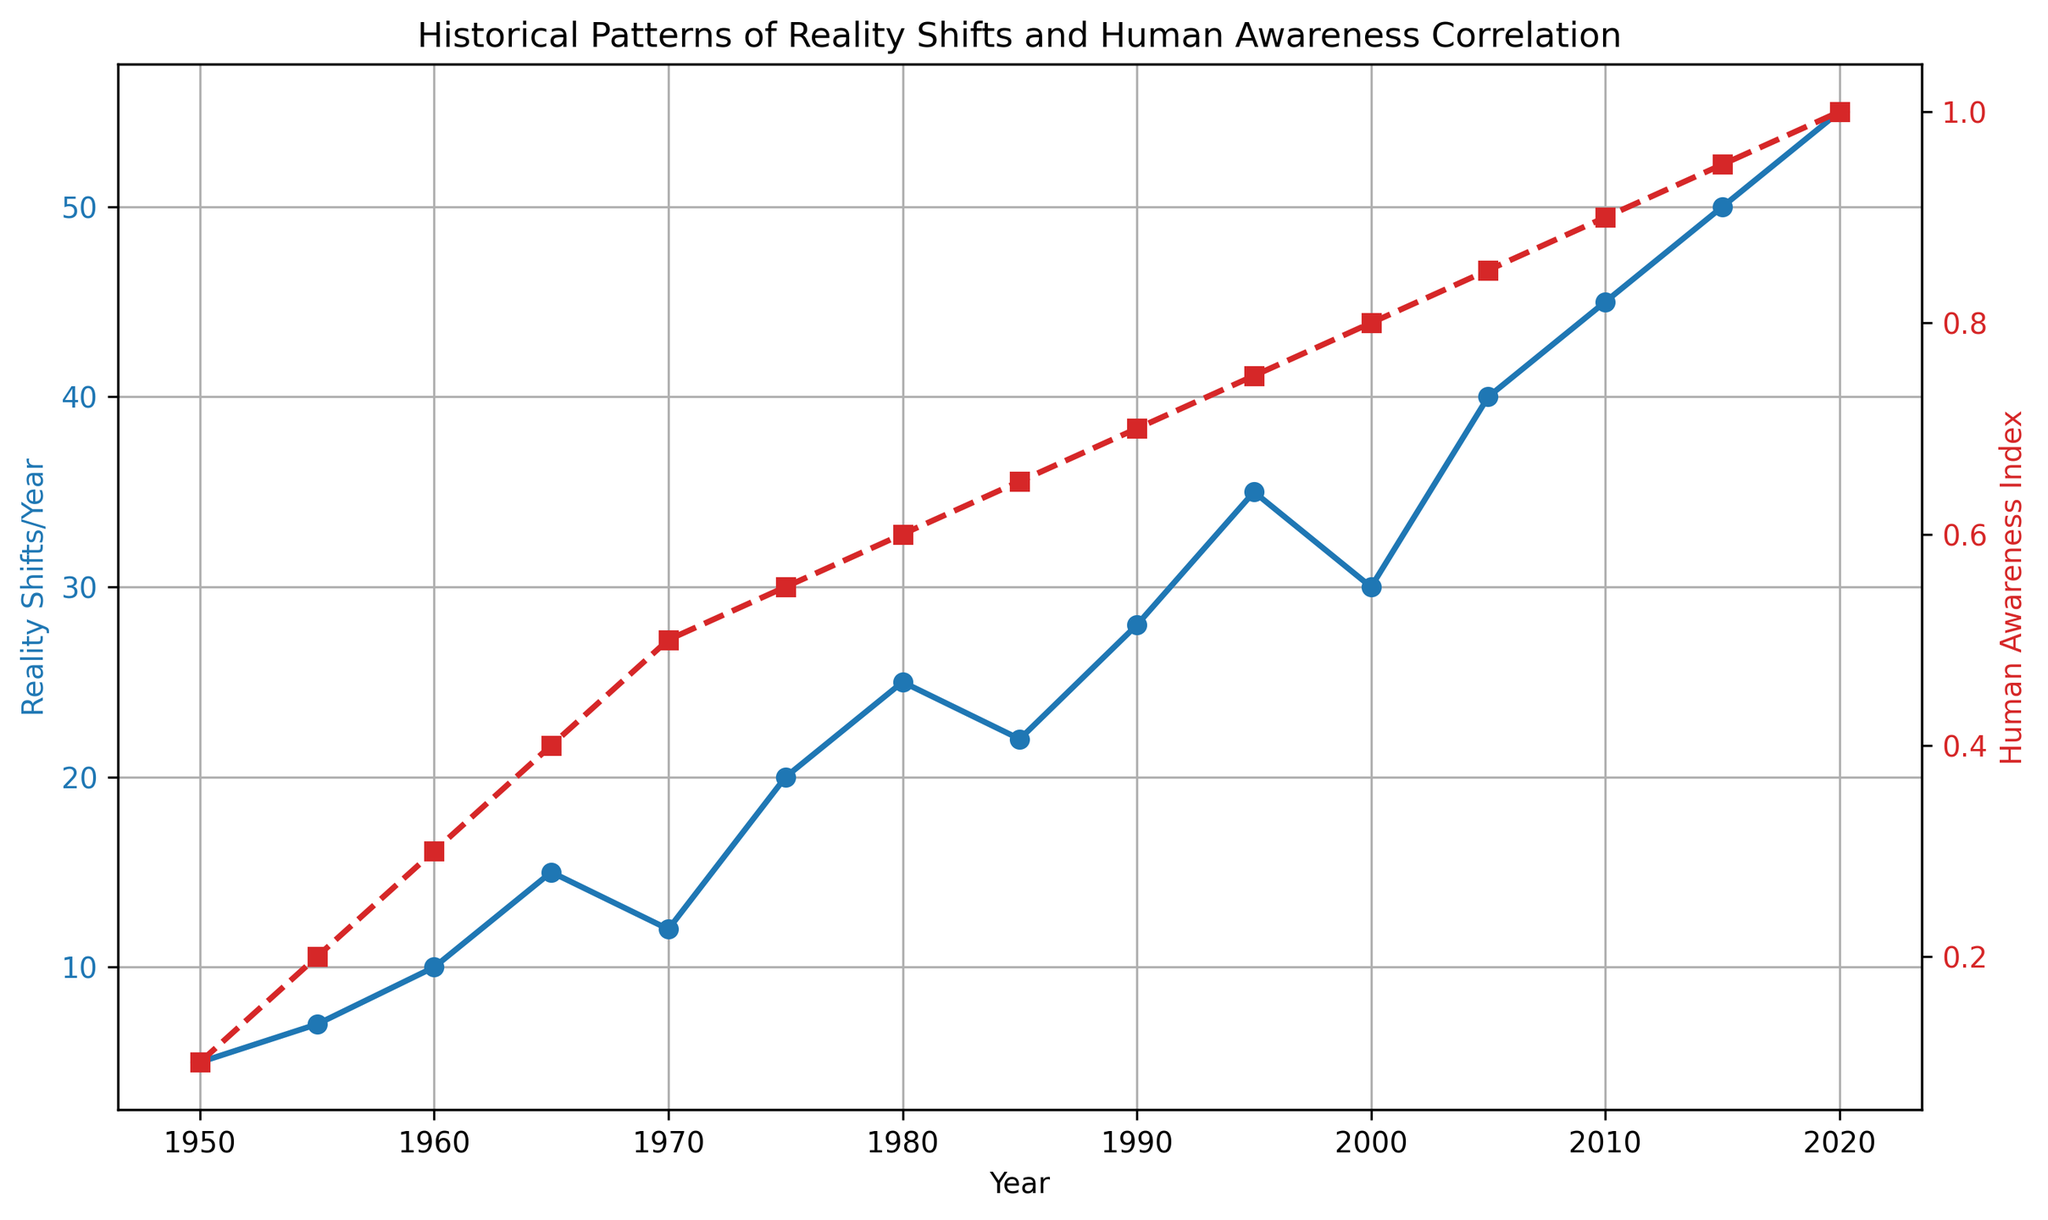What's the trend in Reality Shifts/Year from 1950 to 2020? By observing the blue line (Reality Shifts/Year), you can see a general upward trend with a few fluctuations. Starting from 5 shifts in 1950, it increases overall to 55 shifts in 2020.
Answer: Upward trend How does the Human Awareness Index change between 1950 and 2020? The red dashed line (Human Awareness Index) shows a steady, linear increase from 0.1 in 1950 to 1.0 in 2020.
Answer: Steady increase In which year did Reality Shifts/Year first surpass 20? From the blue line, Reality Shifts/Year first surpasses 20 in 1975.
Answer: 1975 What is the relationship between the Reality Shifts/Year and Human Awareness Index in 1980? In 1980, Reality Shifts/Year is 25 and Human Awareness Index is 0.6. This suggests a positive correlation where higher awareness is related to more reality shifts.
Answer: Positive correlation During which period did the Reality Shifts/Year decrease despite an increase in Human Awareness Index? Between 1965 (15 shifts) and 1970 (12 shifts), the Reality Shifts/Year decreases, even though the Human Awareness Index increases from 0.4 to 0.5.
Answer: 1965 to 1970 What is the average Reality Shifts/Year over the period 1960 to 2020? To find the average, sum the Reality Shifts/Year values from 1960, 1965, 1970, 1975, 1980, 1985, 1990, 1995, 2000, 2005, 2010, 2015, and 2020, and divide by the number of years: \( \frac{10 + 15 + 12 + 20 + 25 + 22 + 28 + 35 + 30 + 40 + 45 + 50 + 55}{13} = 27.69 \)
Answer: 27.69 Which year shows the highest Reality Shifts/Year and what is the corresponding Human Awareness Index? The highest Reality Shifts/Year is in 2020 with 55 shifts; the corresponding Human Awareness Index is 1.0.
Answer: 2020, 1.0 Compare the Reality Shifts/Year and Human Awareness Index between 1990 and 2000. In 1990, Reality Shifts/Year is 28 and Human Awareness Index is 0.7; in 2000, Reality Shifts/Year is 30 and Human Awareness Index is 0.8. Both metrics increase over this decade.
Answer: Both increase By what factor did Reality Shifts/Year increase from 1950 to 2020? Reality Shifts/Year in 1950 is 5, and in 2020 it is 55. The increase factor is \( \frac{55}{5} = 11 \).
Answer: 11 What is the rate of increase in Human Awareness Index per decade between 1950 and 2020? The Human Awareness Index increases from 0.1 in 1950 to 1.0 in 2020. The total increase is 0.9 over 7 decades, so the rate of increase per decade is \( \frac{0.9}{7} \approx 0.1286 \).
Answer: 0.1286 per decade 